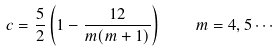Convert formula to latex. <formula><loc_0><loc_0><loc_500><loc_500>c = \frac { 5 } { 2 } \left ( 1 - \frac { 1 2 } { m ( m + 1 ) } \right ) \quad m = 4 , 5 \cdots</formula> 